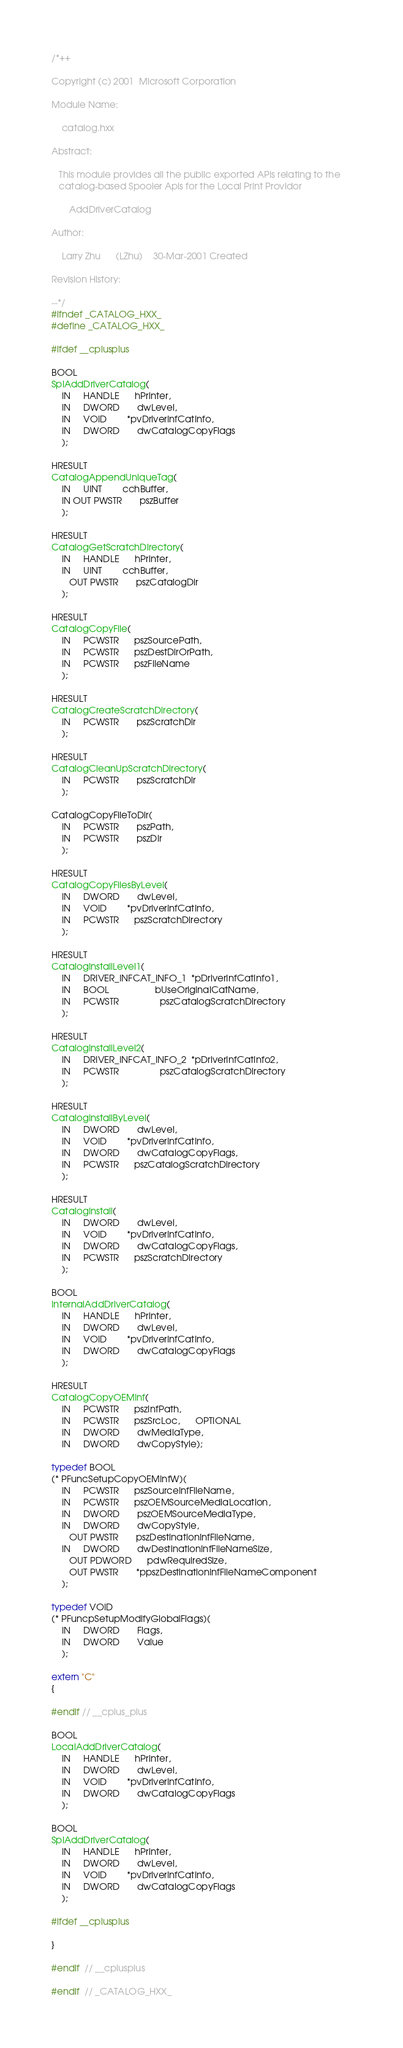<code> <loc_0><loc_0><loc_500><loc_500><_C++_>/*++

Copyright (c) 2001  Microsoft Corporation

Module Name:

    catalog.hxx

Abstract:

   This module provides all the public exported APIs relating to the
   catalog-based Spooler Apis for the Local Print Providor

       AddDriverCatalog
   
Author:

    Larry Zhu      (LZhu)    30-Mar-2001 Created                                         

Revision History:

--*/
#ifndef _CATALOG_HXX_
#define _CATALOG_HXX_

#ifdef __cplusplus

BOOL
SplAddDriverCatalog(
    IN     HANDLE      hPrinter,
    IN     DWORD       dwLevel,
    IN     VOID        *pvDriverInfCatInfo,
    IN     DWORD       dwCatalogCopyFlags
    );

HRESULT
CatalogAppendUniqueTag(
    IN     UINT        cchBuffer,
    IN OUT PWSTR       pszBuffer
    );

HRESULT
CatalogGetScratchDirectory(
    IN     HANDLE      hPrinter,
    IN     UINT        cchBuffer,
       OUT PWSTR       pszCatalogDir
    );

HRESULT
CatalogCopyFile(
    IN     PCWSTR      pszSourcePath,
    IN     PCWSTR      pszDestDirOrPath,
    IN     PCWSTR      pszFileName    
    );

HRESULT
CatalogCreateScratchDirectory(
    IN     PCWSTR       pszScratchDir
    );

HRESULT
CatalogCleanUpScratchDirectory(
    IN     PCWSTR       pszScratchDir   
    );

CatalogCopyFileToDir(
    IN     PCWSTR       pszPath,
    IN     PCWSTR       pszDir
    );

HRESULT
CatalogCopyFilesByLevel(
    IN     DWORD       dwLevel,
    IN     VOID        *pvDriverInfCatInfo,
    IN     PCWSTR      pszScratchDirectory
    );

HRESULT
CatalogInstallLevel1(
    IN     DRIVER_INFCAT_INFO_1  *pDriverInfCatInfo1,
    IN     BOOL                  bUseOriginalCatName,
    IN     PCWSTR                pszCatalogScratchDirectory
    );

HRESULT
CatalogInstallLevel2(
    IN     DRIVER_INFCAT_INFO_2  *pDriverInfCatInfo2,
    IN     PCWSTR                pszCatalogScratchDirectory
    );

HRESULT
CatalogInstallByLevel(
    IN     DWORD       dwLevel,
    IN     VOID        *pvDriverInfCatInfo,
    IN     DWORD       dwCatalogCopyFlags,
    IN     PCWSTR      pszCatalogScratchDirectory
    );

HRESULT
CatalogInstall(
    IN     DWORD       dwLevel,
    IN     VOID        *pvDriverInfCatInfo,
    IN     DWORD       dwCatalogCopyFlags,
    IN     PCWSTR      pszScratchDirectory
    );

BOOL
InternalAddDriverCatalog(
    IN     HANDLE      hPrinter,
    IN     DWORD       dwLevel,
    IN     VOID        *pvDriverInfCatInfo,
    IN     DWORD       dwCatalogCopyFlags
    );

HRESULT
CatalogCopyOEMInf(
    IN     PCWSTR      pszInfPath,
    IN     PCWSTR      pszSrcLoc,      OPTIONAL
    IN     DWORD       dwMediaType,
    IN     DWORD       dwCopyStyle);

typedef BOOL 
(* PFuncSetupCopyOEMInfW)(
    IN     PCWSTR      pszSourceInfFileName,
    IN     PCWSTR      pszOEMSourceMediaLocation,
    IN     DWORD       pszOEMSourceMediaType,
    IN     DWORD       dwCopyStyle,
       OUT PWSTR       pszDestinationInfFileName,
    IN     DWORD       dwDestinationInfFileNameSize,
       OUT PDWORD      pdwRequiredSize,
       OUT PWSTR       *ppszDestinationInfFileNameComponent
    );

typedef VOID 
(* PFuncpSetupModifyGlobalFlags)(
    IN     DWORD       Flags,
    IN     DWORD       Value
    );

extern "C"
{

#endif // __cplus_plus

BOOL
LocalAddDriverCatalog(
    IN     HANDLE      hPrinter,
    IN     DWORD       dwLevel,
    IN     VOID        *pvDriverInfCatInfo,
    IN     DWORD       dwCatalogCopyFlags
    );

BOOL
SplAddDriverCatalog(
    IN     HANDLE      hPrinter,
    IN     DWORD       dwLevel,
    IN     VOID        *pvDriverInfCatInfo,
    IN     DWORD       dwCatalogCopyFlags
    );

#ifdef __cplusplus

}

#endif  // __cplusplus

#endif  // _CATALOG_HXX_

</code> 